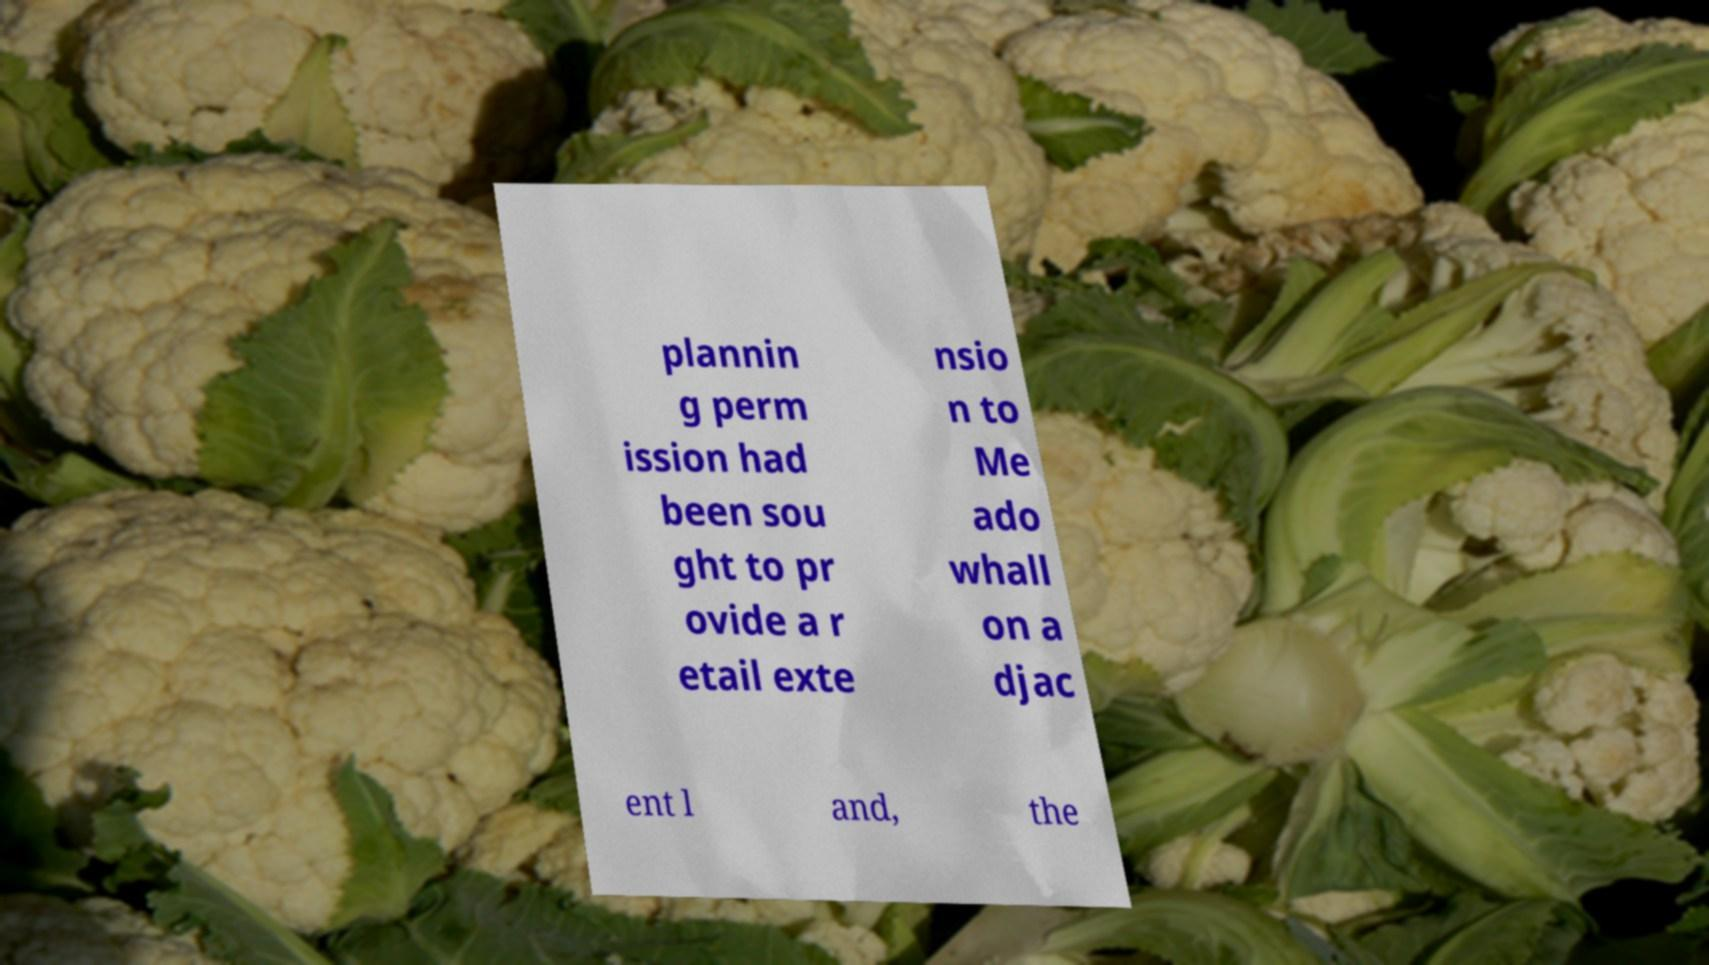Can you accurately transcribe the text from the provided image for me? plannin g perm ission had been sou ght to pr ovide a r etail exte nsio n to Me ado whall on a djac ent l and, the 